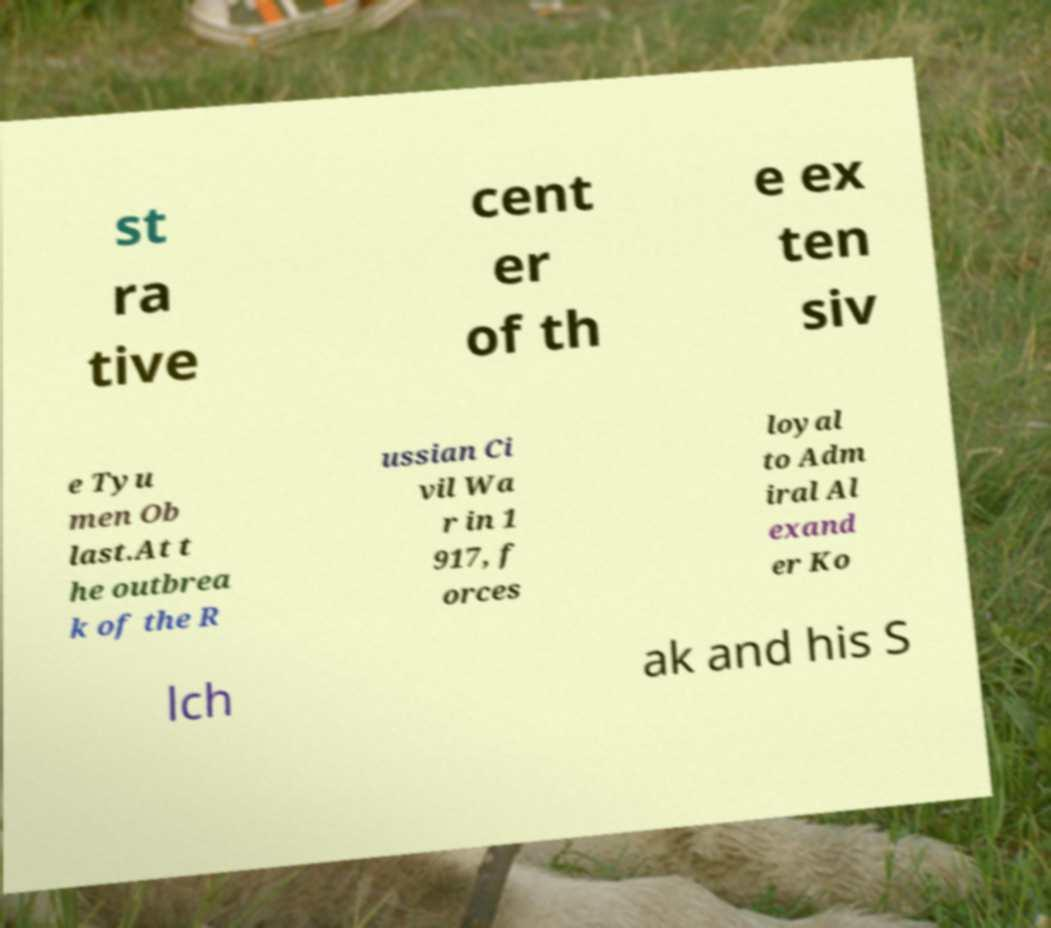For documentation purposes, I need the text within this image transcribed. Could you provide that? st ra tive cent er of th e ex ten siv e Tyu men Ob last.At t he outbrea k of the R ussian Ci vil Wa r in 1 917, f orces loyal to Adm iral Al exand er Ko lch ak and his S 